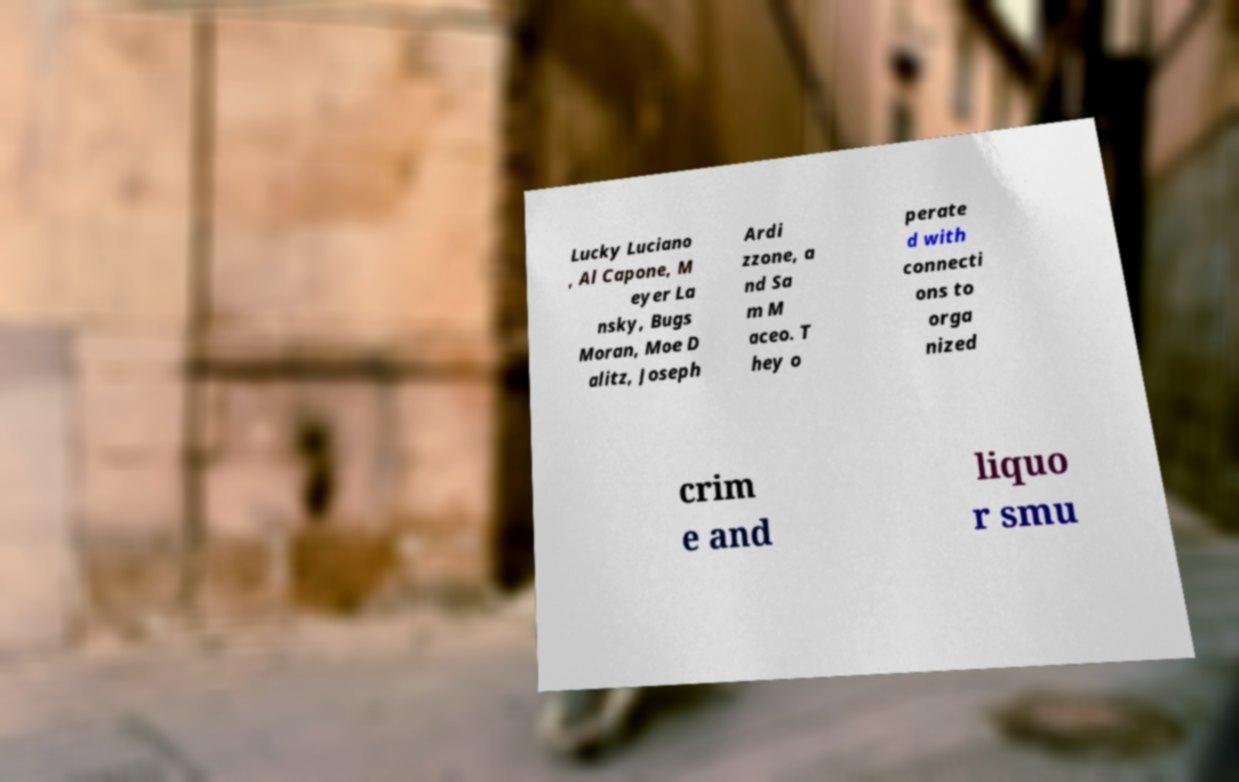Please read and relay the text visible in this image. What does it say? Lucky Luciano , Al Capone, M eyer La nsky, Bugs Moran, Moe D alitz, Joseph Ardi zzone, a nd Sa m M aceo. T hey o perate d with connecti ons to orga nized crim e and liquo r smu 